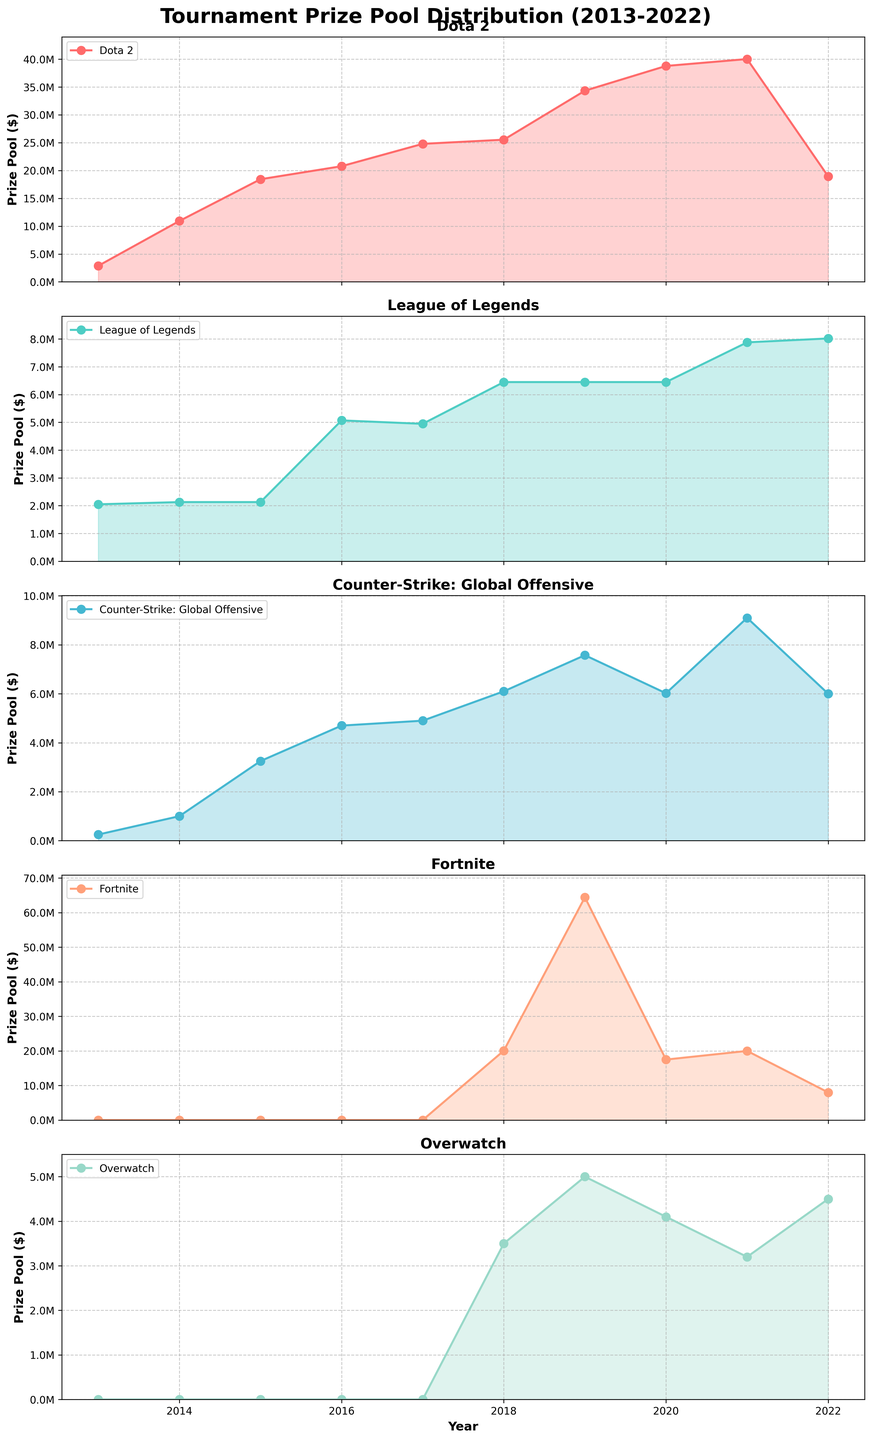How did the prize pool for Dota 2 change over the decade? In the plot for Dota 2, observe the points from 2013 to 2022. The prize pool starts at approximately $2.9M in 2013 and peaks at $40M in 2021. By 2022, it decreases to about $19M. This shows substantial growth with a peak in 2021 and a significant drop thereafter.
Answer: Started at $2.9M, peaked at $40M in 2021, then dropped to $19M Between which years did Fortnite experience the most significant increase in prize pool? Examine the plot for Fortnite and look for the period with the steepest incline. The biggest increase occurs between 2018 and 2019, where the prize pool surged from around $20M to $64.45M.
Answer: Between 2018 and 2019 Which game consistently had the lowest prize pool over the years? By comparing the plots, observe the lowest y-axis values for each year. Overwatch consistently had the lower prize pools compared to other games, peaking around $5M when others were significantly higher.
Answer: Overwatch Which year did League of Legends experience the largest prize pool, and how much was it? Inspect the plot for League of Legends and notice the peak point. In 2022, League of Legends had its highest prize pool, approximately $8M.
Answer: In 2022, approximately $8M Compare the prize pool trends of Dota 2 and Counter-Strike: Global Offensive from 2013 to 2022. What can you conclude? Analyzing both plots over the years: Dota 2 shows a significant and steady increase, peaking in 2021 and then dropping. Counter-Strike: Global Offensive shows a more gradual increase with some fluctuations. The highest prize for Dota 2 ($40M in 2021) is substantially higher than Counter-Strike: Global Offensive ($9.1M in 2021).
Answer: Dota 2 grew significantly with higher peaks, while Counter-Strike grew more gradually and had lower peaks What was the combined prize pool for all games in 2017? Sum the prize pools for each game in 2017: Dota 2 ($24.79M) + League of Legends ($4.95M) + Counter-Strike: Global Offensive ($4.9M) + Fortnite ($0) + Overwatch ($3.5M). The total is $24.79M + $4.95M + $4.9M + $0 + $3.5M = $38.14M.
Answer: $38.14M For which game was the 2022 prize pool significantly lower compared to the previous year? Compare the 2021 and 2022 plots for all games. Noticeable differences include Dota 2 dropping from $40M to $19M.
Answer: Dota 2 In which year did the prize pool for Overwatch peak, and what was the prize amount? Look at the plot for Overwatch and identify the highest point. In 2019, Overwatch’s prize pool peaked at $5M.
Answer: In 2019, $5M What's the average prize pool for League of Legends from 2013 to 2022? Find the sum of League of Legends prize pools and divide by the number of years (10). ($2.05M + $2.13M + $2.13M + $5.07M + $4.95M + $6.45M + $6.45M + $6.45M + $7.88M + $8.02M) = $51.08M. Average is $51.08M / 10 ≈ $5.11M.
Answer: $5.11M 